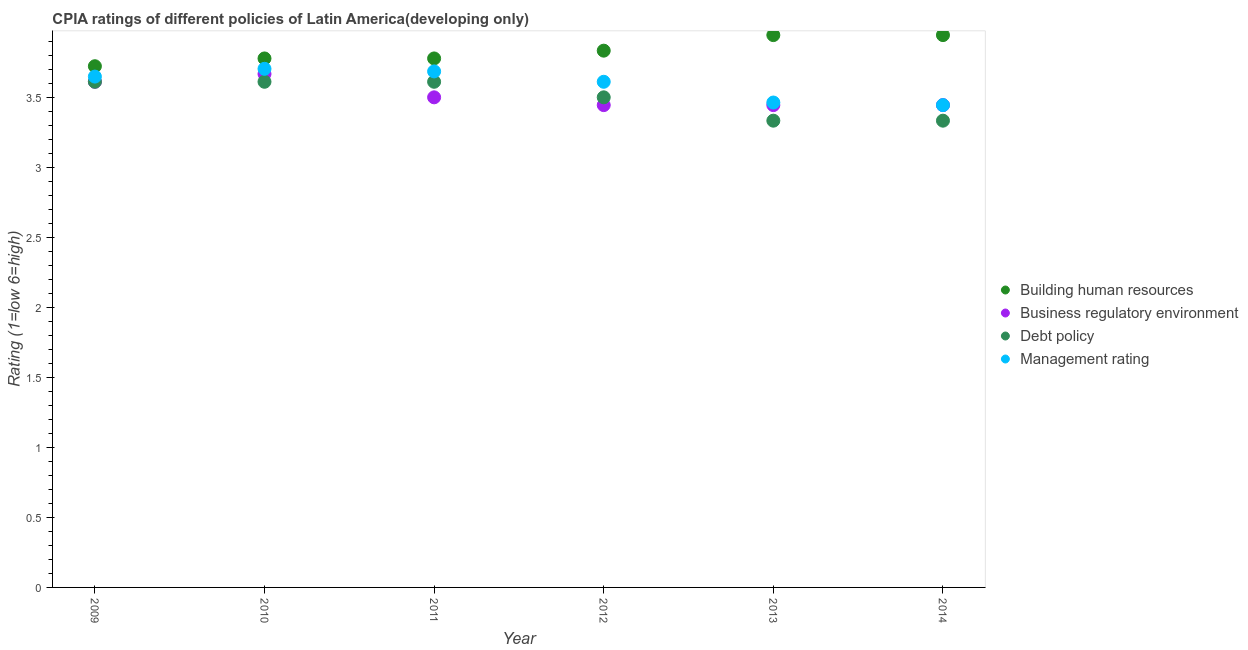How many different coloured dotlines are there?
Make the answer very short. 4. Is the number of dotlines equal to the number of legend labels?
Provide a short and direct response. Yes. What is the cpia rating of debt policy in 2011?
Your answer should be compact. 3.61. Across all years, what is the maximum cpia rating of debt policy?
Keep it short and to the point. 3.61. Across all years, what is the minimum cpia rating of management?
Your answer should be very brief. 3.44. What is the total cpia rating of management in the graph?
Ensure brevity in your answer.  21.56. What is the difference between the cpia rating of debt policy in 2010 and that in 2014?
Your answer should be very brief. 0.28. What is the difference between the cpia rating of management in 2014 and the cpia rating of business regulatory environment in 2013?
Offer a very short reply. 1.1111111200001744e-6. What is the average cpia rating of business regulatory environment per year?
Provide a succinct answer. 3.52. In the year 2012, what is the difference between the cpia rating of business regulatory environment and cpia rating of management?
Your response must be concise. -0.17. What is the difference between the highest and the second highest cpia rating of business regulatory environment?
Provide a short and direct response. 0.06. What is the difference between the highest and the lowest cpia rating of debt policy?
Ensure brevity in your answer.  0.28. Is the sum of the cpia rating of management in 2009 and 2012 greater than the maximum cpia rating of debt policy across all years?
Keep it short and to the point. Yes. Is it the case that in every year, the sum of the cpia rating of management and cpia rating of building human resources is greater than the sum of cpia rating of debt policy and cpia rating of business regulatory environment?
Give a very brief answer. Yes. Is it the case that in every year, the sum of the cpia rating of building human resources and cpia rating of business regulatory environment is greater than the cpia rating of debt policy?
Make the answer very short. Yes. Does the cpia rating of management monotonically increase over the years?
Provide a short and direct response. No. Is the cpia rating of business regulatory environment strictly less than the cpia rating of building human resources over the years?
Make the answer very short. Yes. What is the difference between two consecutive major ticks on the Y-axis?
Provide a succinct answer. 0.5. Where does the legend appear in the graph?
Provide a succinct answer. Center right. What is the title of the graph?
Provide a succinct answer. CPIA ratings of different policies of Latin America(developing only). Does "Efficiency of custom clearance process" appear as one of the legend labels in the graph?
Make the answer very short. No. What is the label or title of the X-axis?
Your response must be concise. Year. What is the label or title of the Y-axis?
Keep it short and to the point. Rating (1=low 6=high). What is the Rating (1=low 6=high) in Building human resources in 2009?
Ensure brevity in your answer.  3.72. What is the Rating (1=low 6=high) of Business regulatory environment in 2009?
Your answer should be compact. 3.61. What is the Rating (1=low 6=high) of Debt policy in 2009?
Give a very brief answer. 3.61. What is the Rating (1=low 6=high) in Management rating in 2009?
Offer a terse response. 3.65. What is the Rating (1=low 6=high) of Building human resources in 2010?
Provide a succinct answer. 3.78. What is the Rating (1=low 6=high) of Business regulatory environment in 2010?
Ensure brevity in your answer.  3.67. What is the Rating (1=low 6=high) of Debt policy in 2010?
Keep it short and to the point. 3.61. What is the Rating (1=low 6=high) in Management rating in 2010?
Offer a very short reply. 3.7. What is the Rating (1=low 6=high) of Building human resources in 2011?
Your answer should be compact. 3.78. What is the Rating (1=low 6=high) of Business regulatory environment in 2011?
Provide a short and direct response. 3.5. What is the Rating (1=low 6=high) of Debt policy in 2011?
Your response must be concise. 3.61. What is the Rating (1=low 6=high) of Management rating in 2011?
Provide a succinct answer. 3.69. What is the Rating (1=low 6=high) of Building human resources in 2012?
Ensure brevity in your answer.  3.83. What is the Rating (1=low 6=high) in Business regulatory environment in 2012?
Make the answer very short. 3.44. What is the Rating (1=low 6=high) in Debt policy in 2012?
Provide a succinct answer. 3.5. What is the Rating (1=low 6=high) of Management rating in 2012?
Your answer should be very brief. 3.61. What is the Rating (1=low 6=high) of Building human resources in 2013?
Your response must be concise. 3.94. What is the Rating (1=low 6=high) of Business regulatory environment in 2013?
Make the answer very short. 3.44. What is the Rating (1=low 6=high) in Debt policy in 2013?
Provide a short and direct response. 3.33. What is the Rating (1=low 6=high) of Management rating in 2013?
Keep it short and to the point. 3.46. What is the Rating (1=low 6=high) of Building human resources in 2014?
Provide a short and direct response. 3.94. What is the Rating (1=low 6=high) in Business regulatory environment in 2014?
Your answer should be very brief. 3.44. What is the Rating (1=low 6=high) in Debt policy in 2014?
Offer a terse response. 3.33. What is the Rating (1=low 6=high) of Management rating in 2014?
Keep it short and to the point. 3.44. Across all years, what is the maximum Rating (1=low 6=high) in Building human resources?
Offer a terse response. 3.94. Across all years, what is the maximum Rating (1=low 6=high) of Business regulatory environment?
Offer a terse response. 3.67. Across all years, what is the maximum Rating (1=low 6=high) in Debt policy?
Your answer should be very brief. 3.61. Across all years, what is the maximum Rating (1=low 6=high) of Management rating?
Keep it short and to the point. 3.7. Across all years, what is the minimum Rating (1=low 6=high) of Building human resources?
Provide a succinct answer. 3.72. Across all years, what is the minimum Rating (1=low 6=high) in Business regulatory environment?
Give a very brief answer. 3.44. Across all years, what is the minimum Rating (1=low 6=high) in Debt policy?
Offer a terse response. 3.33. Across all years, what is the minimum Rating (1=low 6=high) in Management rating?
Your response must be concise. 3.44. What is the total Rating (1=low 6=high) of Building human resources in the graph?
Your answer should be compact. 23. What is the total Rating (1=low 6=high) in Business regulatory environment in the graph?
Keep it short and to the point. 21.11. What is the total Rating (1=low 6=high) in Management rating in the graph?
Make the answer very short. 21.56. What is the difference between the Rating (1=low 6=high) of Building human resources in 2009 and that in 2010?
Ensure brevity in your answer.  -0.06. What is the difference between the Rating (1=low 6=high) of Business regulatory environment in 2009 and that in 2010?
Provide a short and direct response. -0.06. What is the difference between the Rating (1=low 6=high) in Management rating in 2009 and that in 2010?
Make the answer very short. -0.06. What is the difference between the Rating (1=low 6=high) of Building human resources in 2009 and that in 2011?
Provide a succinct answer. -0.06. What is the difference between the Rating (1=low 6=high) in Business regulatory environment in 2009 and that in 2011?
Make the answer very short. 0.11. What is the difference between the Rating (1=low 6=high) of Debt policy in 2009 and that in 2011?
Offer a very short reply. 0. What is the difference between the Rating (1=low 6=high) of Management rating in 2009 and that in 2011?
Keep it short and to the point. -0.04. What is the difference between the Rating (1=low 6=high) of Building human resources in 2009 and that in 2012?
Make the answer very short. -0.11. What is the difference between the Rating (1=low 6=high) in Business regulatory environment in 2009 and that in 2012?
Offer a very short reply. 0.17. What is the difference between the Rating (1=low 6=high) in Management rating in 2009 and that in 2012?
Your answer should be compact. 0.04. What is the difference between the Rating (1=low 6=high) in Building human resources in 2009 and that in 2013?
Your answer should be very brief. -0.22. What is the difference between the Rating (1=low 6=high) of Business regulatory environment in 2009 and that in 2013?
Your answer should be compact. 0.17. What is the difference between the Rating (1=low 6=high) in Debt policy in 2009 and that in 2013?
Provide a short and direct response. 0.28. What is the difference between the Rating (1=low 6=high) in Management rating in 2009 and that in 2013?
Give a very brief answer. 0.19. What is the difference between the Rating (1=low 6=high) of Building human resources in 2009 and that in 2014?
Provide a short and direct response. -0.22. What is the difference between the Rating (1=low 6=high) of Debt policy in 2009 and that in 2014?
Your answer should be very brief. 0.28. What is the difference between the Rating (1=low 6=high) of Management rating in 2009 and that in 2014?
Provide a succinct answer. 0.2. What is the difference between the Rating (1=low 6=high) of Building human resources in 2010 and that in 2011?
Keep it short and to the point. 0. What is the difference between the Rating (1=low 6=high) of Debt policy in 2010 and that in 2011?
Make the answer very short. 0. What is the difference between the Rating (1=low 6=high) of Management rating in 2010 and that in 2011?
Your answer should be very brief. 0.02. What is the difference between the Rating (1=low 6=high) of Building human resources in 2010 and that in 2012?
Your answer should be compact. -0.06. What is the difference between the Rating (1=low 6=high) in Business regulatory environment in 2010 and that in 2012?
Make the answer very short. 0.22. What is the difference between the Rating (1=low 6=high) in Management rating in 2010 and that in 2012?
Ensure brevity in your answer.  0.09. What is the difference between the Rating (1=low 6=high) of Building human resources in 2010 and that in 2013?
Your answer should be very brief. -0.17. What is the difference between the Rating (1=low 6=high) in Business regulatory environment in 2010 and that in 2013?
Offer a terse response. 0.22. What is the difference between the Rating (1=low 6=high) in Debt policy in 2010 and that in 2013?
Ensure brevity in your answer.  0.28. What is the difference between the Rating (1=low 6=high) of Management rating in 2010 and that in 2013?
Keep it short and to the point. 0.24. What is the difference between the Rating (1=low 6=high) of Building human resources in 2010 and that in 2014?
Provide a short and direct response. -0.17. What is the difference between the Rating (1=low 6=high) of Business regulatory environment in 2010 and that in 2014?
Your answer should be compact. 0.22. What is the difference between the Rating (1=low 6=high) in Debt policy in 2010 and that in 2014?
Offer a terse response. 0.28. What is the difference between the Rating (1=low 6=high) in Management rating in 2010 and that in 2014?
Your answer should be compact. 0.26. What is the difference between the Rating (1=low 6=high) in Building human resources in 2011 and that in 2012?
Your answer should be very brief. -0.06. What is the difference between the Rating (1=low 6=high) in Business regulatory environment in 2011 and that in 2012?
Give a very brief answer. 0.06. What is the difference between the Rating (1=low 6=high) in Debt policy in 2011 and that in 2012?
Give a very brief answer. 0.11. What is the difference between the Rating (1=low 6=high) of Management rating in 2011 and that in 2012?
Provide a succinct answer. 0.07. What is the difference between the Rating (1=low 6=high) in Building human resources in 2011 and that in 2013?
Give a very brief answer. -0.17. What is the difference between the Rating (1=low 6=high) in Business regulatory environment in 2011 and that in 2013?
Make the answer very short. 0.06. What is the difference between the Rating (1=low 6=high) of Debt policy in 2011 and that in 2013?
Provide a succinct answer. 0.28. What is the difference between the Rating (1=low 6=high) in Management rating in 2011 and that in 2013?
Give a very brief answer. 0.22. What is the difference between the Rating (1=low 6=high) in Building human resources in 2011 and that in 2014?
Offer a very short reply. -0.17. What is the difference between the Rating (1=low 6=high) in Business regulatory environment in 2011 and that in 2014?
Your answer should be compact. 0.06. What is the difference between the Rating (1=low 6=high) in Debt policy in 2011 and that in 2014?
Give a very brief answer. 0.28. What is the difference between the Rating (1=low 6=high) in Management rating in 2011 and that in 2014?
Ensure brevity in your answer.  0.24. What is the difference between the Rating (1=low 6=high) in Building human resources in 2012 and that in 2013?
Give a very brief answer. -0.11. What is the difference between the Rating (1=low 6=high) in Management rating in 2012 and that in 2013?
Provide a succinct answer. 0.15. What is the difference between the Rating (1=low 6=high) of Building human resources in 2012 and that in 2014?
Provide a succinct answer. -0.11. What is the difference between the Rating (1=low 6=high) in Debt policy in 2012 and that in 2014?
Offer a terse response. 0.17. What is the difference between the Rating (1=low 6=high) of Management rating in 2012 and that in 2014?
Make the answer very short. 0.17. What is the difference between the Rating (1=low 6=high) of Business regulatory environment in 2013 and that in 2014?
Provide a succinct answer. 0. What is the difference between the Rating (1=low 6=high) of Debt policy in 2013 and that in 2014?
Offer a very short reply. 0. What is the difference between the Rating (1=low 6=high) in Management rating in 2013 and that in 2014?
Give a very brief answer. 0.02. What is the difference between the Rating (1=low 6=high) of Building human resources in 2009 and the Rating (1=low 6=high) of Business regulatory environment in 2010?
Provide a succinct answer. 0.06. What is the difference between the Rating (1=low 6=high) of Building human resources in 2009 and the Rating (1=low 6=high) of Management rating in 2010?
Offer a very short reply. 0.02. What is the difference between the Rating (1=low 6=high) in Business regulatory environment in 2009 and the Rating (1=low 6=high) in Debt policy in 2010?
Ensure brevity in your answer.  0. What is the difference between the Rating (1=low 6=high) in Business regulatory environment in 2009 and the Rating (1=low 6=high) in Management rating in 2010?
Offer a very short reply. -0.09. What is the difference between the Rating (1=low 6=high) of Debt policy in 2009 and the Rating (1=low 6=high) of Management rating in 2010?
Ensure brevity in your answer.  -0.09. What is the difference between the Rating (1=low 6=high) in Building human resources in 2009 and the Rating (1=low 6=high) in Business regulatory environment in 2011?
Your response must be concise. 0.22. What is the difference between the Rating (1=low 6=high) of Building human resources in 2009 and the Rating (1=low 6=high) of Debt policy in 2011?
Give a very brief answer. 0.11. What is the difference between the Rating (1=low 6=high) in Building human resources in 2009 and the Rating (1=low 6=high) in Management rating in 2011?
Your answer should be compact. 0.04. What is the difference between the Rating (1=low 6=high) of Business regulatory environment in 2009 and the Rating (1=low 6=high) of Debt policy in 2011?
Your response must be concise. 0. What is the difference between the Rating (1=low 6=high) in Business regulatory environment in 2009 and the Rating (1=low 6=high) in Management rating in 2011?
Give a very brief answer. -0.07. What is the difference between the Rating (1=low 6=high) of Debt policy in 2009 and the Rating (1=low 6=high) of Management rating in 2011?
Offer a terse response. -0.07. What is the difference between the Rating (1=low 6=high) in Building human resources in 2009 and the Rating (1=low 6=high) in Business regulatory environment in 2012?
Ensure brevity in your answer.  0.28. What is the difference between the Rating (1=low 6=high) of Building human resources in 2009 and the Rating (1=low 6=high) of Debt policy in 2012?
Your response must be concise. 0.22. What is the difference between the Rating (1=low 6=high) of Business regulatory environment in 2009 and the Rating (1=low 6=high) of Debt policy in 2012?
Ensure brevity in your answer.  0.11. What is the difference between the Rating (1=low 6=high) in Building human resources in 2009 and the Rating (1=low 6=high) in Business regulatory environment in 2013?
Offer a very short reply. 0.28. What is the difference between the Rating (1=low 6=high) of Building human resources in 2009 and the Rating (1=low 6=high) of Debt policy in 2013?
Ensure brevity in your answer.  0.39. What is the difference between the Rating (1=low 6=high) in Building human resources in 2009 and the Rating (1=low 6=high) in Management rating in 2013?
Make the answer very short. 0.26. What is the difference between the Rating (1=low 6=high) in Business regulatory environment in 2009 and the Rating (1=low 6=high) in Debt policy in 2013?
Offer a terse response. 0.28. What is the difference between the Rating (1=low 6=high) of Business regulatory environment in 2009 and the Rating (1=low 6=high) of Management rating in 2013?
Provide a short and direct response. 0.15. What is the difference between the Rating (1=low 6=high) in Debt policy in 2009 and the Rating (1=low 6=high) in Management rating in 2013?
Offer a terse response. 0.15. What is the difference between the Rating (1=low 6=high) in Building human resources in 2009 and the Rating (1=low 6=high) in Business regulatory environment in 2014?
Provide a short and direct response. 0.28. What is the difference between the Rating (1=low 6=high) in Building human resources in 2009 and the Rating (1=low 6=high) in Debt policy in 2014?
Give a very brief answer. 0.39. What is the difference between the Rating (1=low 6=high) of Building human resources in 2009 and the Rating (1=low 6=high) of Management rating in 2014?
Offer a terse response. 0.28. What is the difference between the Rating (1=low 6=high) in Business regulatory environment in 2009 and the Rating (1=low 6=high) in Debt policy in 2014?
Make the answer very short. 0.28. What is the difference between the Rating (1=low 6=high) of Building human resources in 2010 and the Rating (1=low 6=high) of Business regulatory environment in 2011?
Provide a succinct answer. 0.28. What is the difference between the Rating (1=low 6=high) of Building human resources in 2010 and the Rating (1=low 6=high) of Debt policy in 2011?
Your response must be concise. 0.17. What is the difference between the Rating (1=low 6=high) of Building human resources in 2010 and the Rating (1=low 6=high) of Management rating in 2011?
Your response must be concise. 0.09. What is the difference between the Rating (1=low 6=high) of Business regulatory environment in 2010 and the Rating (1=low 6=high) of Debt policy in 2011?
Your answer should be compact. 0.06. What is the difference between the Rating (1=low 6=high) in Business regulatory environment in 2010 and the Rating (1=low 6=high) in Management rating in 2011?
Keep it short and to the point. -0.02. What is the difference between the Rating (1=low 6=high) in Debt policy in 2010 and the Rating (1=low 6=high) in Management rating in 2011?
Give a very brief answer. -0.07. What is the difference between the Rating (1=low 6=high) of Building human resources in 2010 and the Rating (1=low 6=high) of Debt policy in 2012?
Ensure brevity in your answer.  0.28. What is the difference between the Rating (1=low 6=high) of Building human resources in 2010 and the Rating (1=low 6=high) of Management rating in 2012?
Keep it short and to the point. 0.17. What is the difference between the Rating (1=low 6=high) in Business regulatory environment in 2010 and the Rating (1=low 6=high) in Management rating in 2012?
Offer a very short reply. 0.06. What is the difference between the Rating (1=low 6=high) of Building human resources in 2010 and the Rating (1=low 6=high) of Debt policy in 2013?
Your response must be concise. 0.44. What is the difference between the Rating (1=low 6=high) in Building human resources in 2010 and the Rating (1=low 6=high) in Management rating in 2013?
Offer a very short reply. 0.31. What is the difference between the Rating (1=low 6=high) of Business regulatory environment in 2010 and the Rating (1=low 6=high) of Debt policy in 2013?
Keep it short and to the point. 0.33. What is the difference between the Rating (1=low 6=high) of Business regulatory environment in 2010 and the Rating (1=low 6=high) of Management rating in 2013?
Keep it short and to the point. 0.2. What is the difference between the Rating (1=low 6=high) of Debt policy in 2010 and the Rating (1=low 6=high) of Management rating in 2013?
Ensure brevity in your answer.  0.15. What is the difference between the Rating (1=low 6=high) of Building human resources in 2010 and the Rating (1=low 6=high) of Debt policy in 2014?
Offer a terse response. 0.44. What is the difference between the Rating (1=low 6=high) in Business regulatory environment in 2010 and the Rating (1=low 6=high) in Management rating in 2014?
Ensure brevity in your answer.  0.22. What is the difference between the Rating (1=low 6=high) of Debt policy in 2010 and the Rating (1=low 6=high) of Management rating in 2014?
Provide a succinct answer. 0.17. What is the difference between the Rating (1=low 6=high) in Building human resources in 2011 and the Rating (1=low 6=high) in Business regulatory environment in 2012?
Your response must be concise. 0.33. What is the difference between the Rating (1=low 6=high) of Building human resources in 2011 and the Rating (1=low 6=high) of Debt policy in 2012?
Offer a terse response. 0.28. What is the difference between the Rating (1=low 6=high) in Building human resources in 2011 and the Rating (1=low 6=high) in Management rating in 2012?
Provide a succinct answer. 0.17. What is the difference between the Rating (1=low 6=high) of Business regulatory environment in 2011 and the Rating (1=low 6=high) of Debt policy in 2012?
Offer a very short reply. 0. What is the difference between the Rating (1=low 6=high) in Business regulatory environment in 2011 and the Rating (1=low 6=high) in Management rating in 2012?
Provide a short and direct response. -0.11. What is the difference between the Rating (1=low 6=high) in Building human resources in 2011 and the Rating (1=low 6=high) in Debt policy in 2013?
Ensure brevity in your answer.  0.44. What is the difference between the Rating (1=low 6=high) in Building human resources in 2011 and the Rating (1=low 6=high) in Management rating in 2013?
Your answer should be compact. 0.31. What is the difference between the Rating (1=low 6=high) of Business regulatory environment in 2011 and the Rating (1=low 6=high) of Debt policy in 2013?
Offer a terse response. 0.17. What is the difference between the Rating (1=low 6=high) in Business regulatory environment in 2011 and the Rating (1=low 6=high) in Management rating in 2013?
Offer a terse response. 0.04. What is the difference between the Rating (1=low 6=high) of Debt policy in 2011 and the Rating (1=low 6=high) of Management rating in 2013?
Your response must be concise. 0.15. What is the difference between the Rating (1=low 6=high) in Building human resources in 2011 and the Rating (1=low 6=high) in Debt policy in 2014?
Ensure brevity in your answer.  0.44. What is the difference between the Rating (1=low 6=high) of Business regulatory environment in 2011 and the Rating (1=low 6=high) of Management rating in 2014?
Offer a terse response. 0.06. What is the difference between the Rating (1=low 6=high) in Debt policy in 2011 and the Rating (1=low 6=high) in Management rating in 2014?
Provide a short and direct response. 0.17. What is the difference between the Rating (1=low 6=high) of Building human resources in 2012 and the Rating (1=low 6=high) of Business regulatory environment in 2013?
Ensure brevity in your answer.  0.39. What is the difference between the Rating (1=low 6=high) in Building human resources in 2012 and the Rating (1=low 6=high) in Management rating in 2013?
Provide a succinct answer. 0.37. What is the difference between the Rating (1=low 6=high) of Business regulatory environment in 2012 and the Rating (1=low 6=high) of Debt policy in 2013?
Ensure brevity in your answer.  0.11. What is the difference between the Rating (1=low 6=high) in Business regulatory environment in 2012 and the Rating (1=low 6=high) in Management rating in 2013?
Provide a succinct answer. -0.02. What is the difference between the Rating (1=low 6=high) in Debt policy in 2012 and the Rating (1=low 6=high) in Management rating in 2013?
Provide a short and direct response. 0.04. What is the difference between the Rating (1=low 6=high) of Building human resources in 2012 and the Rating (1=low 6=high) of Business regulatory environment in 2014?
Ensure brevity in your answer.  0.39. What is the difference between the Rating (1=low 6=high) of Building human resources in 2012 and the Rating (1=low 6=high) of Debt policy in 2014?
Provide a succinct answer. 0.5. What is the difference between the Rating (1=low 6=high) in Building human resources in 2012 and the Rating (1=low 6=high) in Management rating in 2014?
Your answer should be very brief. 0.39. What is the difference between the Rating (1=low 6=high) of Debt policy in 2012 and the Rating (1=low 6=high) of Management rating in 2014?
Provide a succinct answer. 0.06. What is the difference between the Rating (1=low 6=high) in Building human resources in 2013 and the Rating (1=low 6=high) in Business regulatory environment in 2014?
Your answer should be very brief. 0.5. What is the difference between the Rating (1=low 6=high) of Building human resources in 2013 and the Rating (1=low 6=high) of Debt policy in 2014?
Offer a terse response. 0.61. What is the difference between the Rating (1=low 6=high) of Building human resources in 2013 and the Rating (1=low 6=high) of Management rating in 2014?
Your response must be concise. 0.5. What is the difference between the Rating (1=low 6=high) in Business regulatory environment in 2013 and the Rating (1=low 6=high) in Debt policy in 2014?
Offer a terse response. 0.11. What is the difference between the Rating (1=low 6=high) of Business regulatory environment in 2013 and the Rating (1=low 6=high) of Management rating in 2014?
Your answer should be very brief. -0. What is the difference between the Rating (1=low 6=high) in Debt policy in 2013 and the Rating (1=low 6=high) in Management rating in 2014?
Provide a succinct answer. -0.11. What is the average Rating (1=low 6=high) of Building human resources per year?
Your answer should be compact. 3.83. What is the average Rating (1=low 6=high) in Business regulatory environment per year?
Your response must be concise. 3.52. What is the average Rating (1=low 6=high) in Management rating per year?
Your response must be concise. 3.59. In the year 2009, what is the difference between the Rating (1=low 6=high) of Building human resources and Rating (1=low 6=high) of Business regulatory environment?
Give a very brief answer. 0.11. In the year 2009, what is the difference between the Rating (1=low 6=high) of Building human resources and Rating (1=low 6=high) of Management rating?
Provide a short and direct response. 0.07. In the year 2009, what is the difference between the Rating (1=low 6=high) of Business regulatory environment and Rating (1=low 6=high) of Debt policy?
Your answer should be very brief. 0. In the year 2009, what is the difference between the Rating (1=low 6=high) of Business regulatory environment and Rating (1=low 6=high) of Management rating?
Your response must be concise. -0.04. In the year 2009, what is the difference between the Rating (1=low 6=high) of Debt policy and Rating (1=low 6=high) of Management rating?
Your answer should be very brief. -0.04. In the year 2010, what is the difference between the Rating (1=low 6=high) in Building human resources and Rating (1=low 6=high) in Management rating?
Keep it short and to the point. 0.07. In the year 2010, what is the difference between the Rating (1=low 6=high) of Business regulatory environment and Rating (1=low 6=high) of Debt policy?
Offer a terse response. 0.06. In the year 2010, what is the difference between the Rating (1=low 6=high) in Business regulatory environment and Rating (1=low 6=high) in Management rating?
Your answer should be compact. -0.04. In the year 2010, what is the difference between the Rating (1=low 6=high) in Debt policy and Rating (1=low 6=high) in Management rating?
Provide a succinct answer. -0.09. In the year 2011, what is the difference between the Rating (1=low 6=high) in Building human resources and Rating (1=low 6=high) in Business regulatory environment?
Provide a succinct answer. 0.28. In the year 2011, what is the difference between the Rating (1=low 6=high) in Building human resources and Rating (1=low 6=high) in Management rating?
Your answer should be very brief. 0.09. In the year 2011, what is the difference between the Rating (1=low 6=high) of Business regulatory environment and Rating (1=low 6=high) of Debt policy?
Your response must be concise. -0.11. In the year 2011, what is the difference between the Rating (1=low 6=high) in Business regulatory environment and Rating (1=low 6=high) in Management rating?
Your answer should be compact. -0.19. In the year 2011, what is the difference between the Rating (1=low 6=high) in Debt policy and Rating (1=low 6=high) in Management rating?
Make the answer very short. -0.07. In the year 2012, what is the difference between the Rating (1=low 6=high) of Building human resources and Rating (1=low 6=high) of Business regulatory environment?
Your answer should be very brief. 0.39. In the year 2012, what is the difference between the Rating (1=low 6=high) of Building human resources and Rating (1=low 6=high) of Management rating?
Provide a succinct answer. 0.22. In the year 2012, what is the difference between the Rating (1=low 6=high) of Business regulatory environment and Rating (1=low 6=high) of Debt policy?
Keep it short and to the point. -0.06. In the year 2012, what is the difference between the Rating (1=low 6=high) of Debt policy and Rating (1=low 6=high) of Management rating?
Provide a short and direct response. -0.11. In the year 2013, what is the difference between the Rating (1=low 6=high) of Building human resources and Rating (1=low 6=high) of Business regulatory environment?
Ensure brevity in your answer.  0.5. In the year 2013, what is the difference between the Rating (1=low 6=high) of Building human resources and Rating (1=low 6=high) of Debt policy?
Provide a succinct answer. 0.61. In the year 2013, what is the difference between the Rating (1=low 6=high) in Building human resources and Rating (1=low 6=high) in Management rating?
Keep it short and to the point. 0.48. In the year 2013, what is the difference between the Rating (1=low 6=high) of Business regulatory environment and Rating (1=low 6=high) of Debt policy?
Your answer should be compact. 0.11. In the year 2013, what is the difference between the Rating (1=low 6=high) in Business regulatory environment and Rating (1=low 6=high) in Management rating?
Your answer should be very brief. -0.02. In the year 2013, what is the difference between the Rating (1=low 6=high) of Debt policy and Rating (1=low 6=high) of Management rating?
Offer a terse response. -0.13. In the year 2014, what is the difference between the Rating (1=low 6=high) in Building human resources and Rating (1=low 6=high) in Business regulatory environment?
Offer a terse response. 0.5. In the year 2014, what is the difference between the Rating (1=low 6=high) of Building human resources and Rating (1=low 6=high) of Debt policy?
Give a very brief answer. 0.61. In the year 2014, what is the difference between the Rating (1=low 6=high) in Business regulatory environment and Rating (1=low 6=high) in Debt policy?
Make the answer very short. 0.11. In the year 2014, what is the difference between the Rating (1=low 6=high) in Business regulatory environment and Rating (1=low 6=high) in Management rating?
Your response must be concise. -0. In the year 2014, what is the difference between the Rating (1=low 6=high) of Debt policy and Rating (1=low 6=high) of Management rating?
Provide a succinct answer. -0.11. What is the ratio of the Rating (1=low 6=high) in Building human resources in 2009 to that in 2010?
Keep it short and to the point. 0.99. What is the ratio of the Rating (1=low 6=high) of Debt policy in 2009 to that in 2010?
Ensure brevity in your answer.  1. What is the ratio of the Rating (1=low 6=high) of Management rating in 2009 to that in 2010?
Your answer should be compact. 0.98. What is the ratio of the Rating (1=low 6=high) in Business regulatory environment in 2009 to that in 2011?
Your answer should be compact. 1.03. What is the ratio of the Rating (1=low 6=high) in Building human resources in 2009 to that in 2012?
Offer a very short reply. 0.97. What is the ratio of the Rating (1=low 6=high) in Business regulatory environment in 2009 to that in 2012?
Provide a short and direct response. 1.05. What is the ratio of the Rating (1=low 6=high) in Debt policy in 2009 to that in 2012?
Provide a short and direct response. 1.03. What is the ratio of the Rating (1=low 6=high) in Management rating in 2009 to that in 2012?
Make the answer very short. 1.01. What is the ratio of the Rating (1=low 6=high) in Building human resources in 2009 to that in 2013?
Your response must be concise. 0.94. What is the ratio of the Rating (1=low 6=high) of Business regulatory environment in 2009 to that in 2013?
Your answer should be very brief. 1.05. What is the ratio of the Rating (1=low 6=high) of Management rating in 2009 to that in 2013?
Your answer should be compact. 1.05. What is the ratio of the Rating (1=low 6=high) of Building human resources in 2009 to that in 2014?
Provide a succinct answer. 0.94. What is the ratio of the Rating (1=low 6=high) in Business regulatory environment in 2009 to that in 2014?
Make the answer very short. 1.05. What is the ratio of the Rating (1=low 6=high) of Management rating in 2009 to that in 2014?
Your response must be concise. 1.06. What is the ratio of the Rating (1=low 6=high) of Business regulatory environment in 2010 to that in 2011?
Give a very brief answer. 1.05. What is the ratio of the Rating (1=low 6=high) in Management rating in 2010 to that in 2011?
Your answer should be compact. 1. What is the ratio of the Rating (1=low 6=high) of Building human resources in 2010 to that in 2012?
Provide a succinct answer. 0.99. What is the ratio of the Rating (1=low 6=high) in Business regulatory environment in 2010 to that in 2012?
Give a very brief answer. 1.06. What is the ratio of the Rating (1=low 6=high) in Debt policy in 2010 to that in 2012?
Provide a short and direct response. 1.03. What is the ratio of the Rating (1=low 6=high) in Management rating in 2010 to that in 2012?
Make the answer very short. 1.03. What is the ratio of the Rating (1=low 6=high) in Building human resources in 2010 to that in 2013?
Give a very brief answer. 0.96. What is the ratio of the Rating (1=low 6=high) of Business regulatory environment in 2010 to that in 2013?
Make the answer very short. 1.06. What is the ratio of the Rating (1=low 6=high) in Management rating in 2010 to that in 2013?
Make the answer very short. 1.07. What is the ratio of the Rating (1=low 6=high) in Building human resources in 2010 to that in 2014?
Offer a very short reply. 0.96. What is the ratio of the Rating (1=low 6=high) in Business regulatory environment in 2010 to that in 2014?
Offer a very short reply. 1.06. What is the ratio of the Rating (1=low 6=high) in Debt policy in 2010 to that in 2014?
Ensure brevity in your answer.  1.08. What is the ratio of the Rating (1=low 6=high) of Management rating in 2010 to that in 2014?
Your answer should be compact. 1.08. What is the ratio of the Rating (1=low 6=high) in Building human resources in 2011 to that in 2012?
Provide a succinct answer. 0.99. What is the ratio of the Rating (1=low 6=high) in Business regulatory environment in 2011 to that in 2012?
Your answer should be compact. 1.02. What is the ratio of the Rating (1=low 6=high) of Debt policy in 2011 to that in 2012?
Your answer should be compact. 1.03. What is the ratio of the Rating (1=low 6=high) in Management rating in 2011 to that in 2012?
Give a very brief answer. 1.02. What is the ratio of the Rating (1=low 6=high) in Building human resources in 2011 to that in 2013?
Provide a short and direct response. 0.96. What is the ratio of the Rating (1=low 6=high) of Business regulatory environment in 2011 to that in 2013?
Provide a short and direct response. 1.02. What is the ratio of the Rating (1=low 6=high) of Management rating in 2011 to that in 2013?
Your answer should be compact. 1.06. What is the ratio of the Rating (1=low 6=high) in Building human resources in 2011 to that in 2014?
Provide a succinct answer. 0.96. What is the ratio of the Rating (1=low 6=high) of Business regulatory environment in 2011 to that in 2014?
Offer a terse response. 1.02. What is the ratio of the Rating (1=low 6=high) in Management rating in 2011 to that in 2014?
Provide a succinct answer. 1.07. What is the ratio of the Rating (1=low 6=high) of Building human resources in 2012 to that in 2013?
Offer a very short reply. 0.97. What is the ratio of the Rating (1=low 6=high) of Debt policy in 2012 to that in 2013?
Provide a short and direct response. 1.05. What is the ratio of the Rating (1=low 6=high) in Management rating in 2012 to that in 2013?
Offer a terse response. 1.04. What is the ratio of the Rating (1=low 6=high) of Building human resources in 2012 to that in 2014?
Offer a very short reply. 0.97. What is the ratio of the Rating (1=low 6=high) in Management rating in 2012 to that in 2014?
Your response must be concise. 1.05. What is the ratio of the Rating (1=low 6=high) of Building human resources in 2013 to that in 2014?
Your answer should be compact. 1. What is the ratio of the Rating (1=low 6=high) of Debt policy in 2013 to that in 2014?
Give a very brief answer. 1. What is the ratio of the Rating (1=low 6=high) in Management rating in 2013 to that in 2014?
Give a very brief answer. 1.01. What is the difference between the highest and the second highest Rating (1=low 6=high) of Building human resources?
Ensure brevity in your answer.  0. What is the difference between the highest and the second highest Rating (1=low 6=high) in Business regulatory environment?
Keep it short and to the point. 0.06. What is the difference between the highest and the second highest Rating (1=low 6=high) of Management rating?
Your answer should be compact. 0.02. What is the difference between the highest and the lowest Rating (1=low 6=high) of Building human resources?
Make the answer very short. 0.22. What is the difference between the highest and the lowest Rating (1=low 6=high) in Business regulatory environment?
Give a very brief answer. 0.22. What is the difference between the highest and the lowest Rating (1=low 6=high) of Debt policy?
Your answer should be very brief. 0.28. What is the difference between the highest and the lowest Rating (1=low 6=high) in Management rating?
Provide a short and direct response. 0.26. 